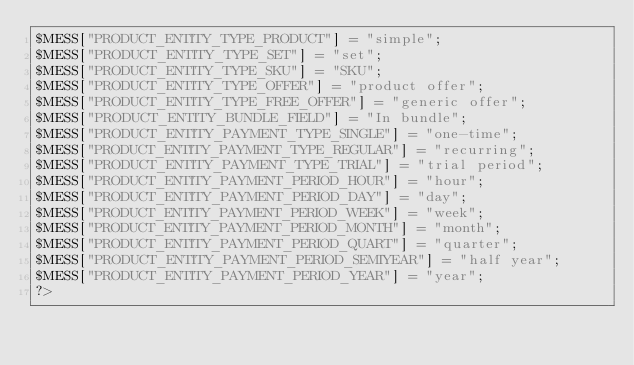<code> <loc_0><loc_0><loc_500><loc_500><_PHP_>$MESS["PRODUCT_ENTITY_TYPE_PRODUCT"] = "simple";
$MESS["PRODUCT_ENTITY_TYPE_SET"] = "set";
$MESS["PRODUCT_ENTITY_TYPE_SKU"] = "SKU";
$MESS["PRODUCT_ENTITY_TYPE_OFFER"] = "product offer";
$MESS["PRODUCT_ENTITY_TYPE_FREE_OFFER"] = "generic offer";
$MESS["PRODUCT_ENTITY_BUNDLE_FIELD"] = "In bundle";
$MESS["PRODUCT_ENTITY_PAYMENT_TYPE_SINGLE"] = "one-time";
$MESS["PRODUCT_ENTITY_PAYMENT_TYPE_REGULAR"] = "recurring";
$MESS["PRODUCT_ENTITY_PAYMENT_TYPE_TRIAL"] = "trial period";
$MESS["PRODUCT_ENTITY_PAYMENT_PERIOD_HOUR"] = "hour";
$MESS["PRODUCT_ENTITY_PAYMENT_PERIOD_DAY"] = "day";
$MESS["PRODUCT_ENTITY_PAYMENT_PERIOD_WEEK"] = "week";
$MESS["PRODUCT_ENTITY_PAYMENT_PERIOD_MONTH"] = "month";
$MESS["PRODUCT_ENTITY_PAYMENT_PERIOD_QUART"] = "quarter";
$MESS["PRODUCT_ENTITY_PAYMENT_PERIOD_SEMIYEAR"] = "half year";
$MESS["PRODUCT_ENTITY_PAYMENT_PERIOD_YEAR"] = "year";
?></code> 